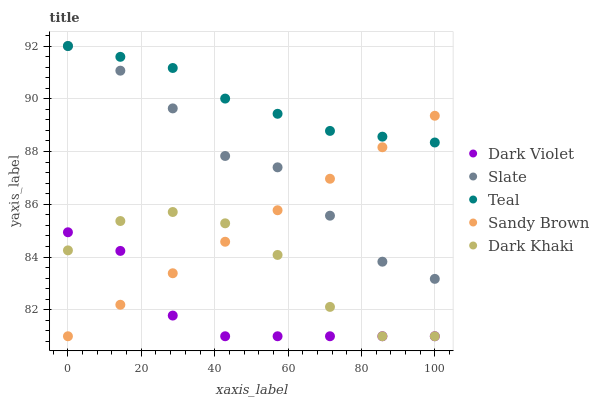Does Dark Violet have the minimum area under the curve?
Answer yes or no. Yes. Does Teal have the maximum area under the curve?
Answer yes or no. Yes. Does Slate have the minimum area under the curve?
Answer yes or no. No. Does Slate have the maximum area under the curve?
Answer yes or no. No. Is Sandy Brown the smoothest?
Answer yes or no. Yes. Is Dark Khaki the roughest?
Answer yes or no. Yes. Is Slate the smoothest?
Answer yes or no. No. Is Slate the roughest?
Answer yes or no. No. Does Dark Khaki have the lowest value?
Answer yes or no. Yes. Does Slate have the lowest value?
Answer yes or no. No. Does Teal have the highest value?
Answer yes or no. Yes. Does Sandy Brown have the highest value?
Answer yes or no. No. Is Dark Violet less than Teal?
Answer yes or no. Yes. Is Slate greater than Dark Khaki?
Answer yes or no. Yes. Does Slate intersect Sandy Brown?
Answer yes or no. Yes. Is Slate less than Sandy Brown?
Answer yes or no. No. Is Slate greater than Sandy Brown?
Answer yes or no. No. Does Dark Violet intersect Teal?
Answer yes or no. No. 